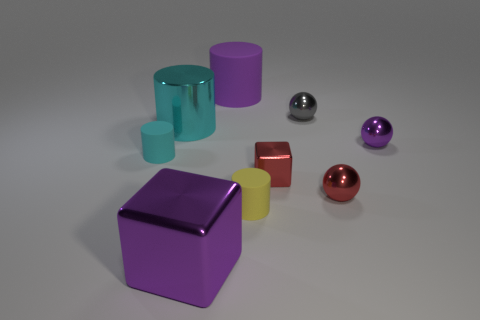There is a purple shiny object to the right of the yellow object behind the purple metal object that is in front of the tiny cube; what is its shape?
Your answer should be compact. Sphere. What number of other things are the same shape as the small cyan matte thing?
Provide a short and direct response. 3. What is the color of the block that is the same size as the purple cylinder?
Ensure brevity in your answer.  Purple. What number of spheres are small gray metal things or big green matte things?
Offer a very short reply. 1. How many large cyan shiny balls are there?
Your answer should be compact. 0. Do the big rubber thing and the big metal thing that is behind the cyan matte thing have the same shape?
Offer a very short reply. Yes. What size is the ball that is the same color as the tiny metal block?
Ensure brevity in your answer.  Small. What number of things are either large blocks or red things?
Keep it short and to the point. 3. There is a big purple thing in front of the object that is left of the big cyan shiny object; what is its shape?
Provide a short and direct response. Cube. There is a object behind the tiny gray shiny object; does it have the same shape as the cyan rubber thing?
Your answer should be compact. Yes. 